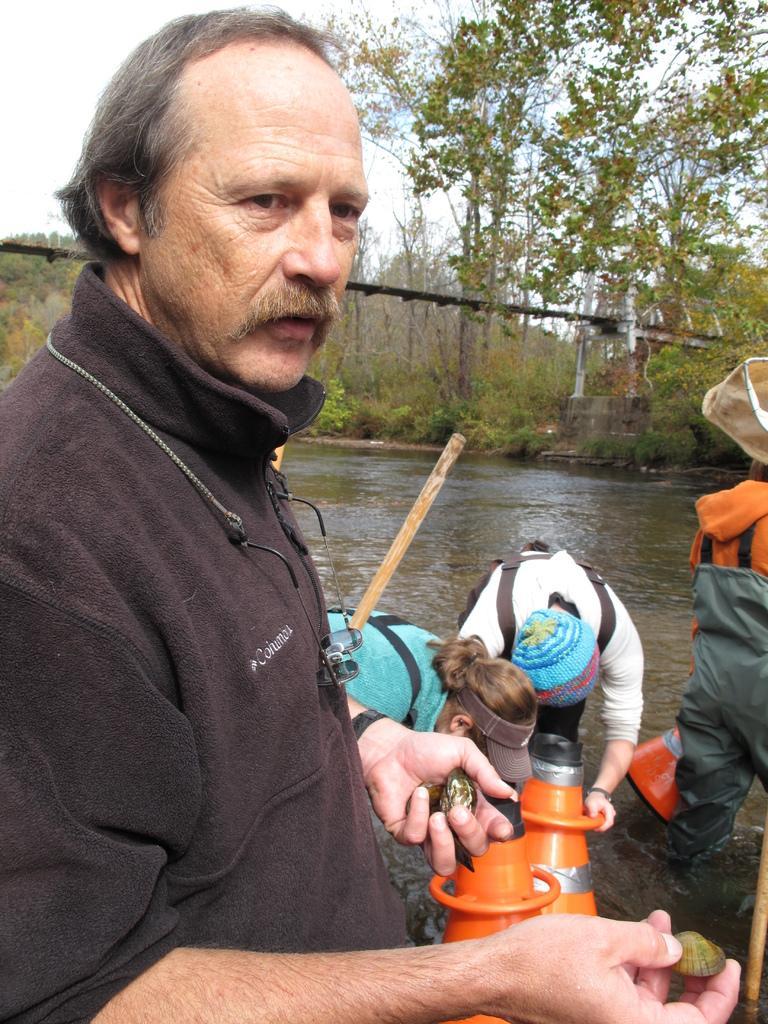Please provide a concise description of this image. In this image, I can see four persons standing and there are objects in the water. In the background, I can see the trees, a bridge and the sky. 